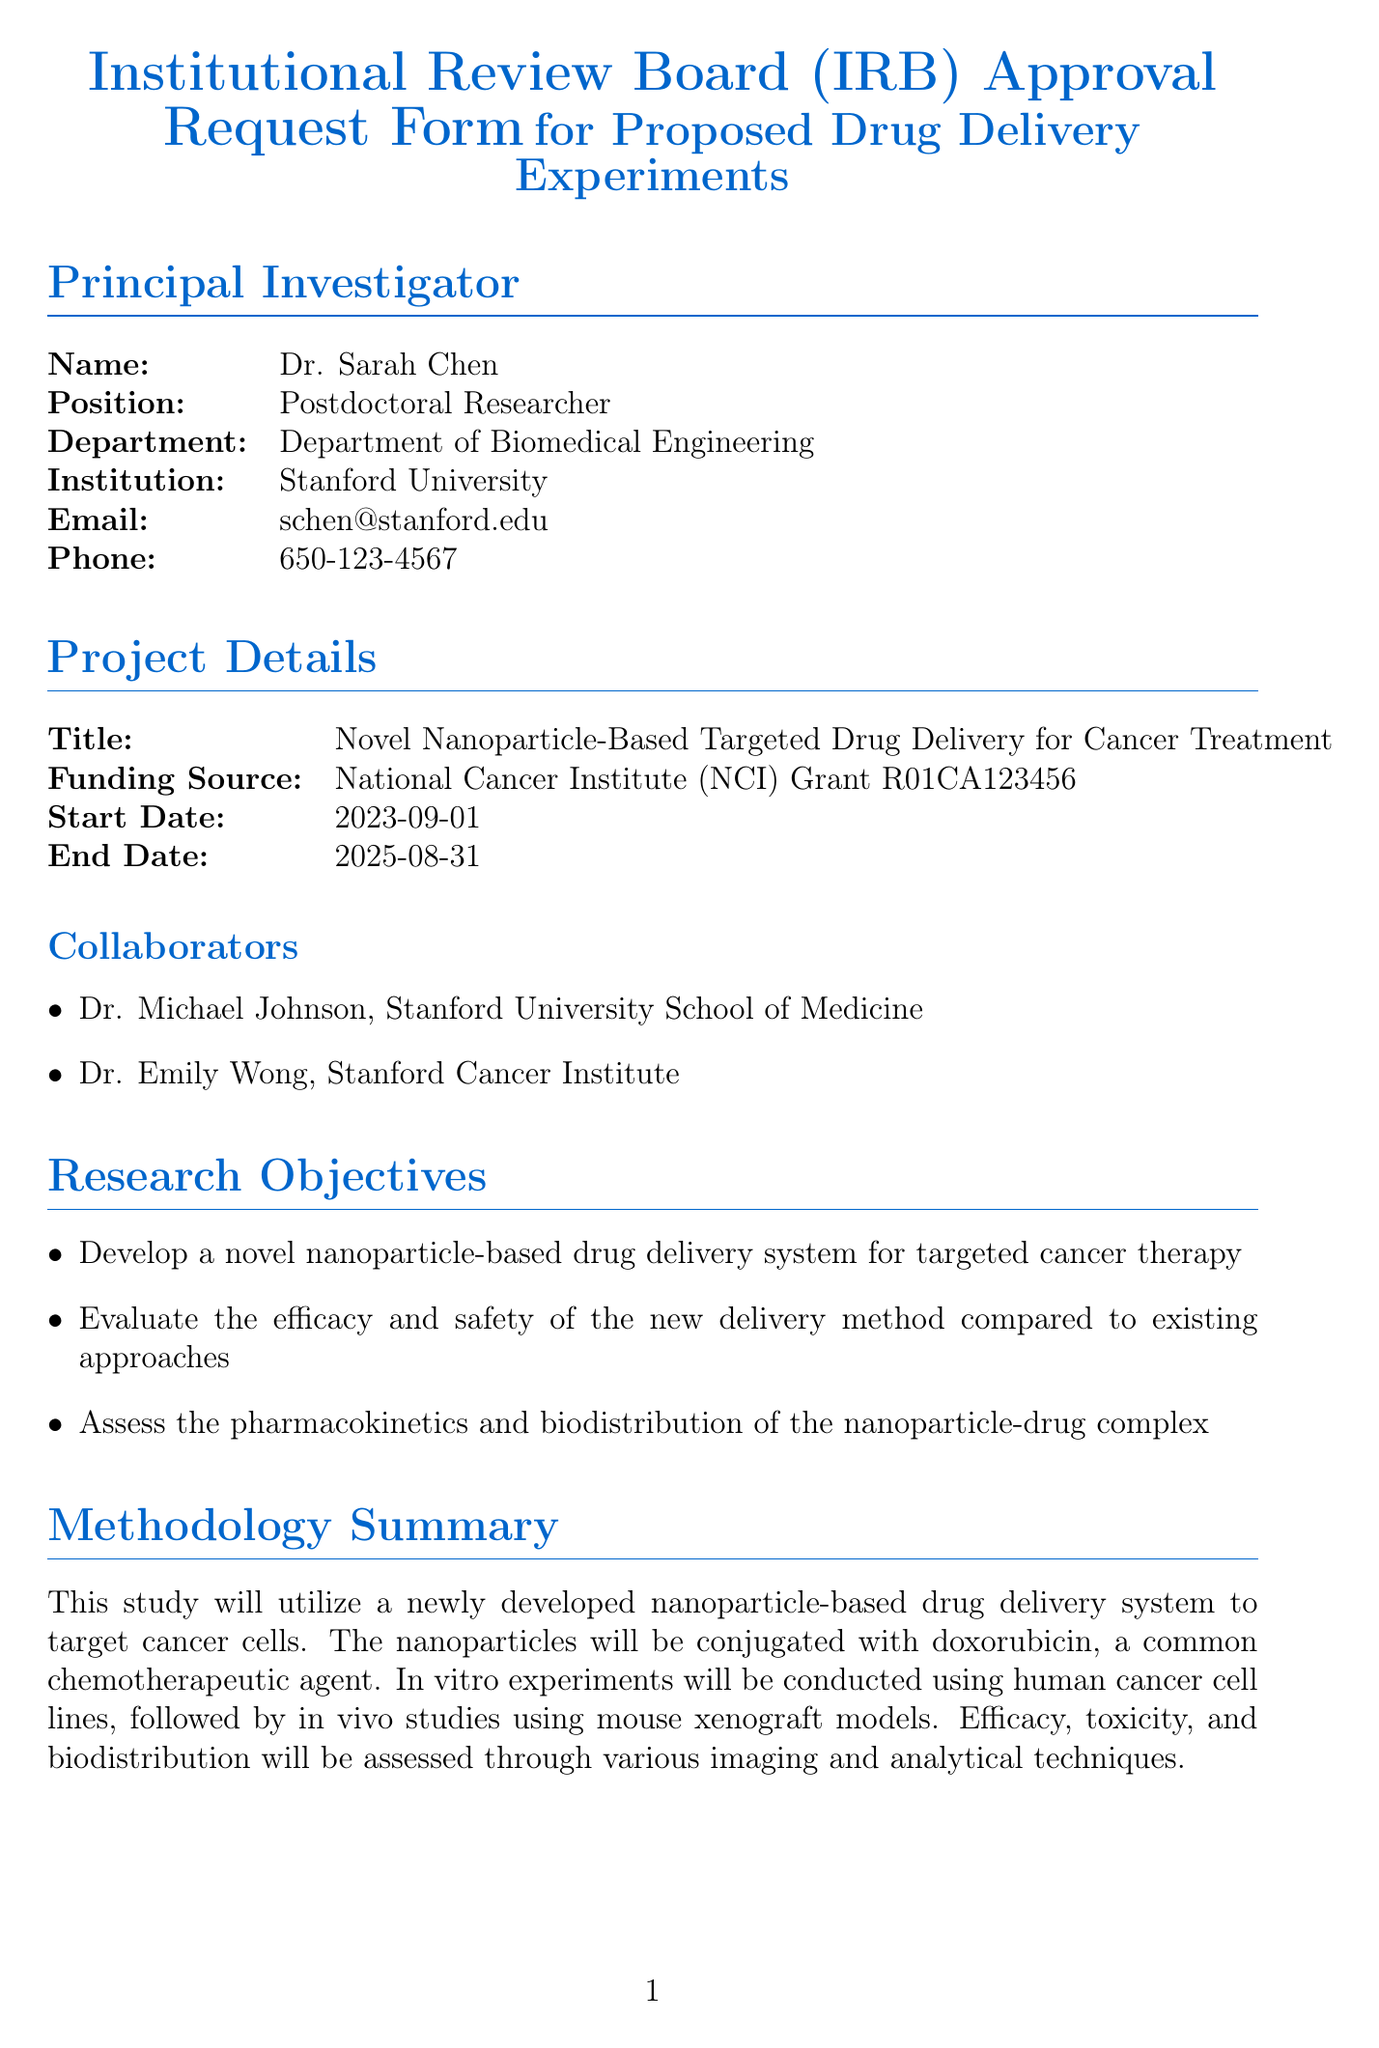What is the principal investigator's name? The principal investigator is listed at the top of the document with their specific details.
Answer: Dr. Sarah Chen What is the title of the project? The title of the project is provided in the project details section of the document.
Answer: Novel Nanoparticle-Based Targeted Drug Delivery for Cancer Treatment What is the animal species used in the study? The document specifies the species of animal subjects in the subject information section.
Answer: Mus musculus (BALB/c nude mice) How many animals are involved in the study? The number of animals is explicitly mentioned in the subject information section of the document.
Answer: 120 What is the start date of the project? The start date is found in the project details section and is crucial for understanding the project timeline.
Answer: 2023-09-01 What are the potential risks associated with the project? The document lists potential risks in the risk assessment section, showing concerns regarding the experimental methods.
Answer: Toxicity from nanoparticles or chemotherapeutic agents What biosafety level has been assigned to this research? The biosafety level is indicated in the biosafety section of the document, revealing safety measures in place.
Answer: BSL-2 What is the funding source for the project? The funding source is specified in the project details section as it indicates financial support and credibility.
Answer: National Cancer Institute (NCI) Grant R01CA123456 